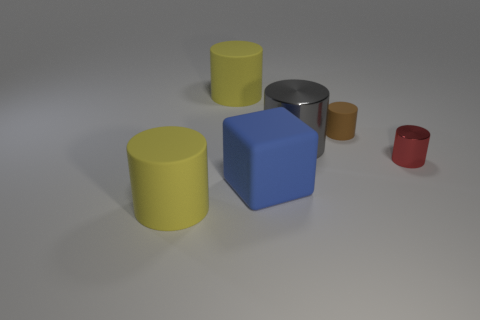Subtract all brown cylinders. How many cylinders are left? 4 Subtract all yellow cylinders. How many cylinders are left? 3 Add 1 tiny blocks. How many tiny blocks exist? 1 Add 3 matte cylinders. How many objects exist? 9 Subtract 1 gray cylinders. How many objects are left? 5 Subtract all cylinders. How many objects are left? 1 Subtract 3 cylinders. How many cylinders are left? 2 Subtract all red cylinders. Subtract all cyan spheres. How many cylinders are left? 4 Subtract all purple cubes. How many brown cylinders are left? 1 Subtract all large shiny objects. Subtract all brown rubber cylinders. How many objects are left? 4 